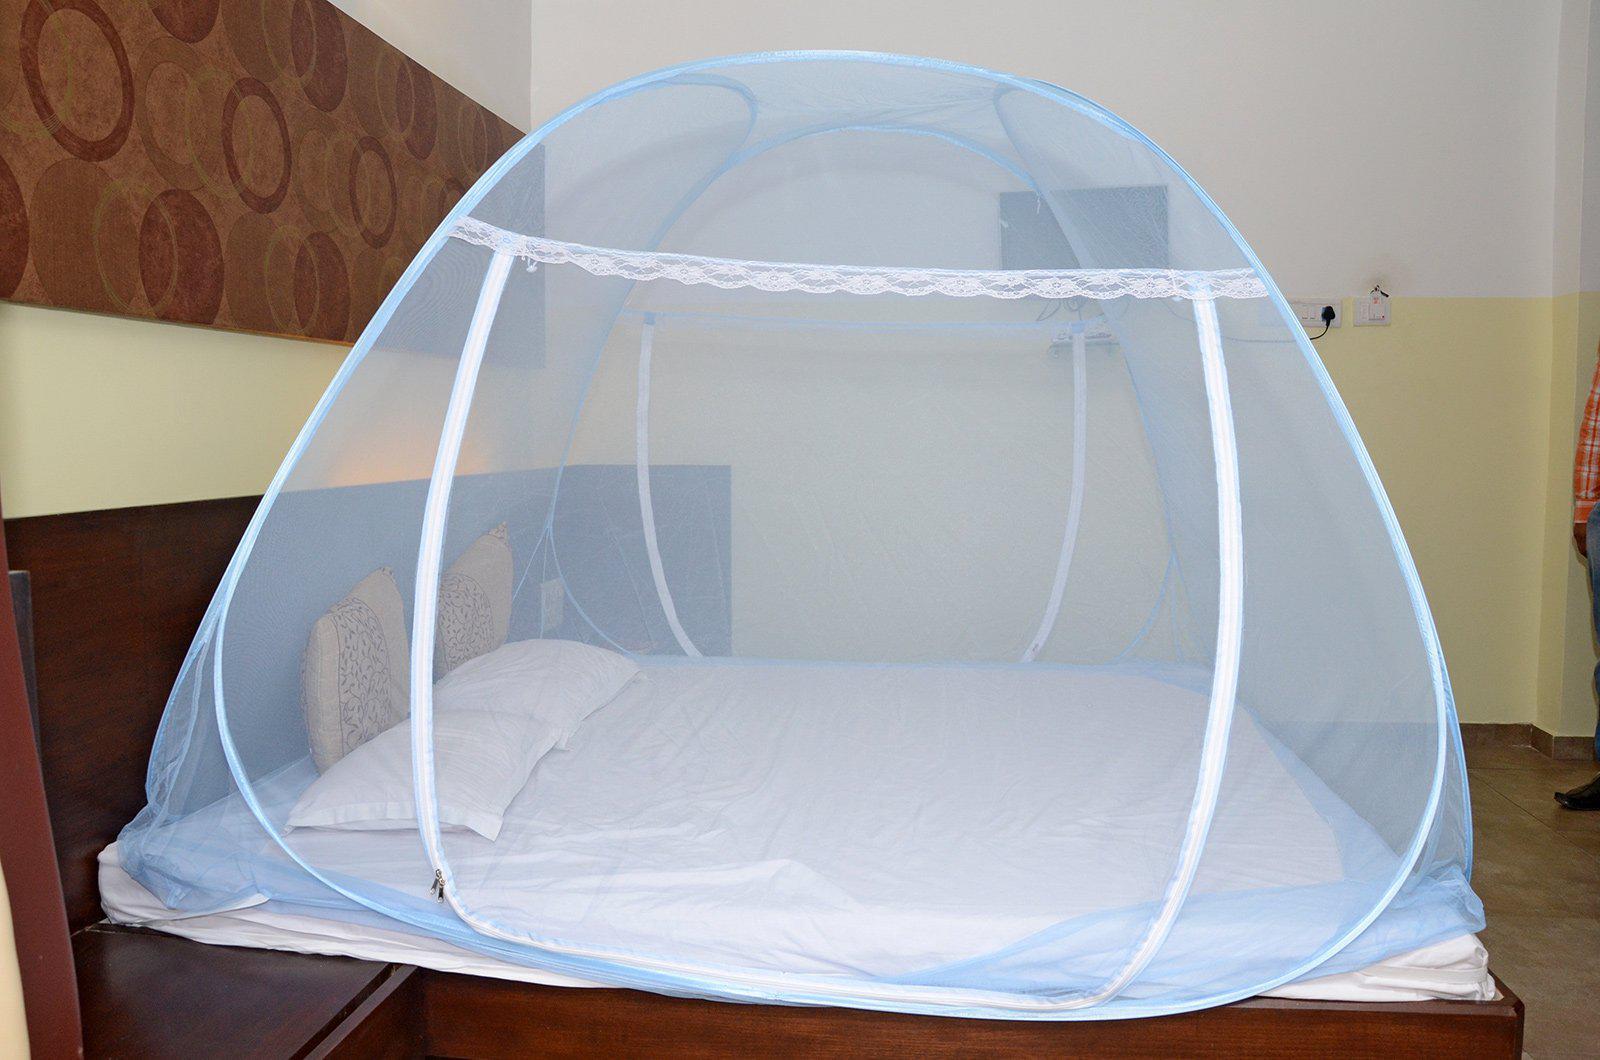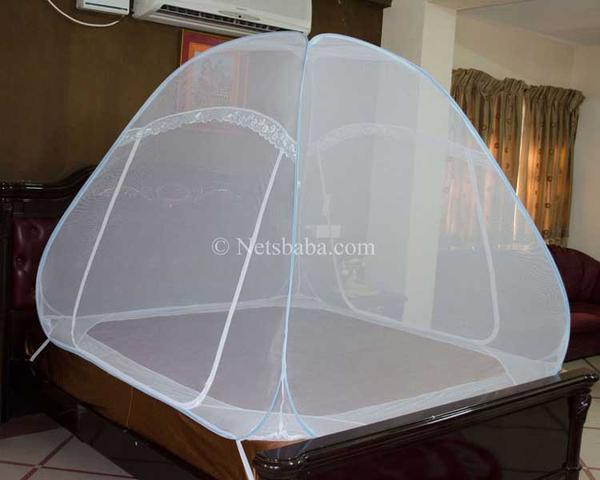The first image is the image on the left, the second image is the image on the right. Considering the images on both sides, is "In the image to the right, the bed-tent is white." valid? Answer yes or no. Yes. The first image is the image on the left, the second image is the image on the right. Analyze the images presented: Is the assertion "There are two canopies tents." valid? Answer yes or no. Yes. 